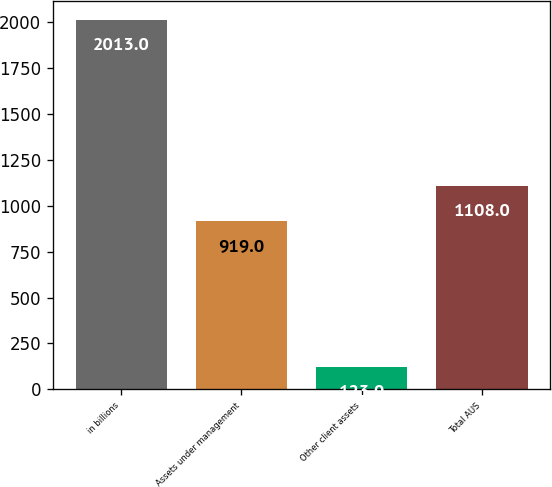Convert chart. <chart><loc_0><loc_0><loc_500><loc_500><bar_chart><fcel>in billions<fcel>Assets under management<fcel>Other client assets<fcel>Total AUS<nl><fcel>2013<fcel>919<fcel>123<fcel>1108<nl></chart> 